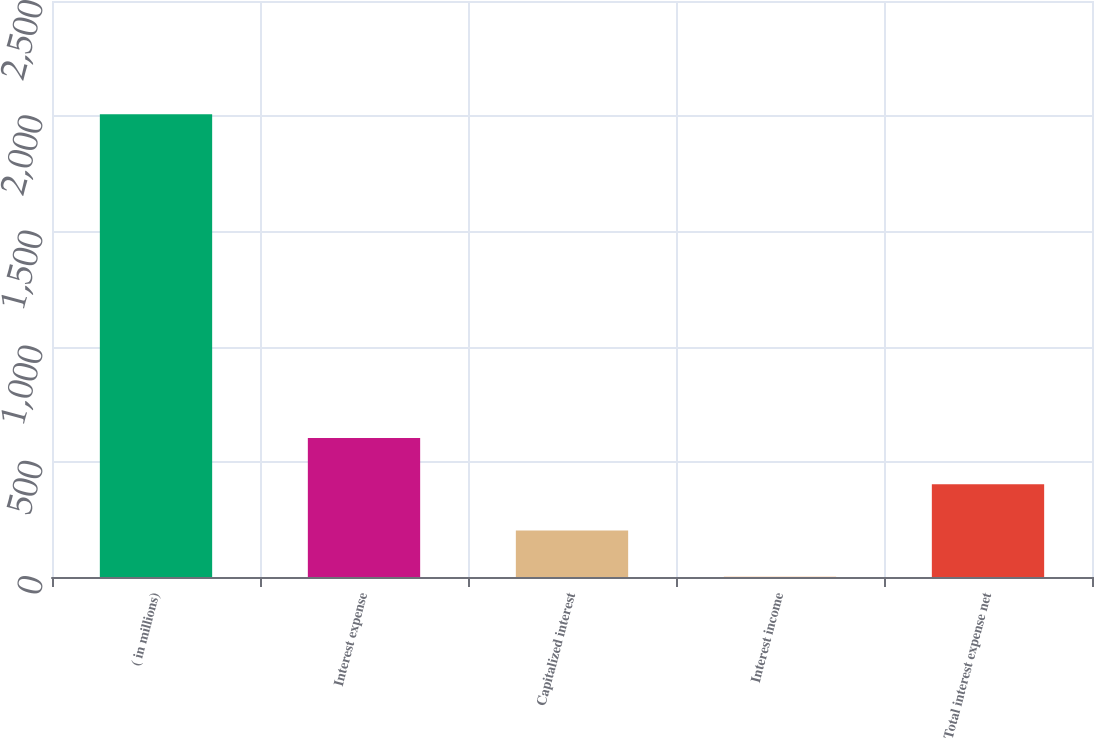Convert chart to OTSL. <chart><loc_0><loc_0><loc_500><loc_500><bar_chart><fcel>( in millions)<fcel>Interest expense<fcel>Capitalized interest<fcel>Interest income<fcel>Total interest expense net<nl><fcel>2009<fcel>603.26<fcel>201.62<fcel>0.8<fcel>402.44<nl></chart> 